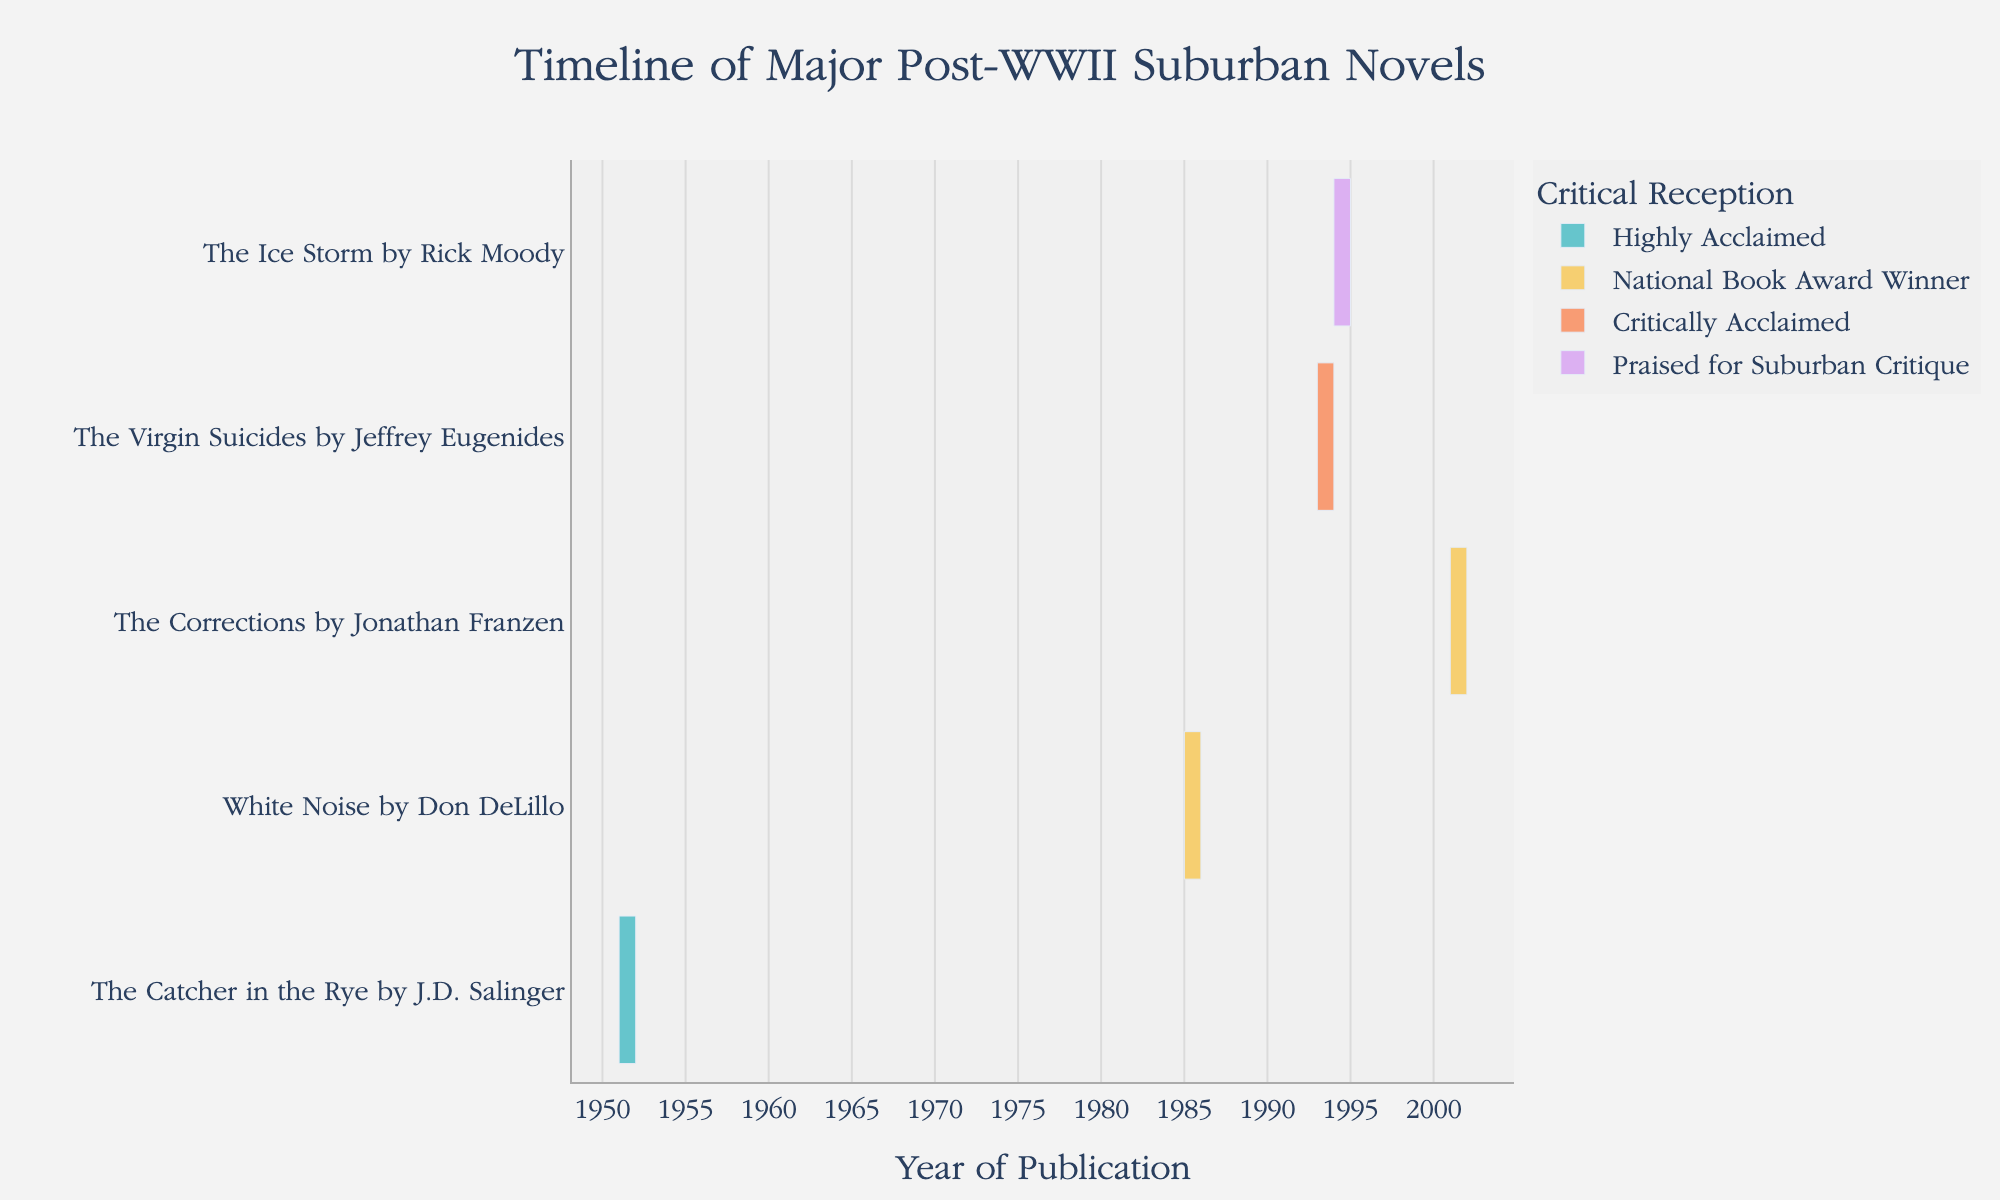What is the title of the figure? The title is usually displayed at the top of the figure and gives an indication of what the chart represents. In this case, it states, "Timeline of Major Post-WWII Suburban Novels."
Answer: Timeline of Major Post-WWII Suburban Novels What are the start and end years of "The Catcher in the Rye" by J.D. Salinger? Look for "The Catcher in the Rye" in the list of tasks and refer to its corresponding start and end points on the x-axis to find the years.
Answer: 1951 to 1952 How many novels are shown in the Gantt chart? Count the total number of unique tasks (novels) listed on the y-axis.
Answer: 5 Which novel had its publication and critical reception span from 1994 to 1995? Check the Gantt chart for the one corresponding to these dates on the x-axis. The y-axis shows that "The Ice Storm" by Rick Moody matches these dates.
Answer: "The Ice Storm" by Rick Moody Which novels won the National Book Award, and in what years were they published? Look for the "Reception" field labeled as "National Book Award Winner" and check their corresponding start years. "White Noise" and "The Corrections" match this criteria.
Answer: "White Noise" (1985) and "The Corrections" (2001) Which novel had the longest span between its publication year and the next year? Compare the span between the start and end years of each novel by checking the x-axis positions.
Answer: "The Catcher in the Rye" (1 year span) In which decade were the most novels published according to the chart? Check the x-axis to see the decades where the start years of the novels fall. Count the novels per decade and identify which has the most. The 1990s have three novels.
Answer: 1990s Compare the critical acclaims of "The Virgin Suicides" and "The Ice Storm." Which one was critically acclaimed, and which one was praised for suburban critique? Locate the novels on the y-axis and read the "Reception" field for each.
Answer: "The Virgin Suicides" was Critically Acclaimed; "The Ice Storm" was Praised for Suburban Critique Which novel was published earliest? Find the novel with the earliest start year on the x-axis.
Answer: "The Catcher in the Rye" (1951) Are there any novels that have an overlap in their publication years? Check the start and end years on the x-axis for overlaps. "The Virgin Suicides" (1993-1994) and "The Ice Storm" (1994-1995) overlap in 1994.
Answer: Yes, "The Virgin Suicides" and "The Ice Storm" in 1994 